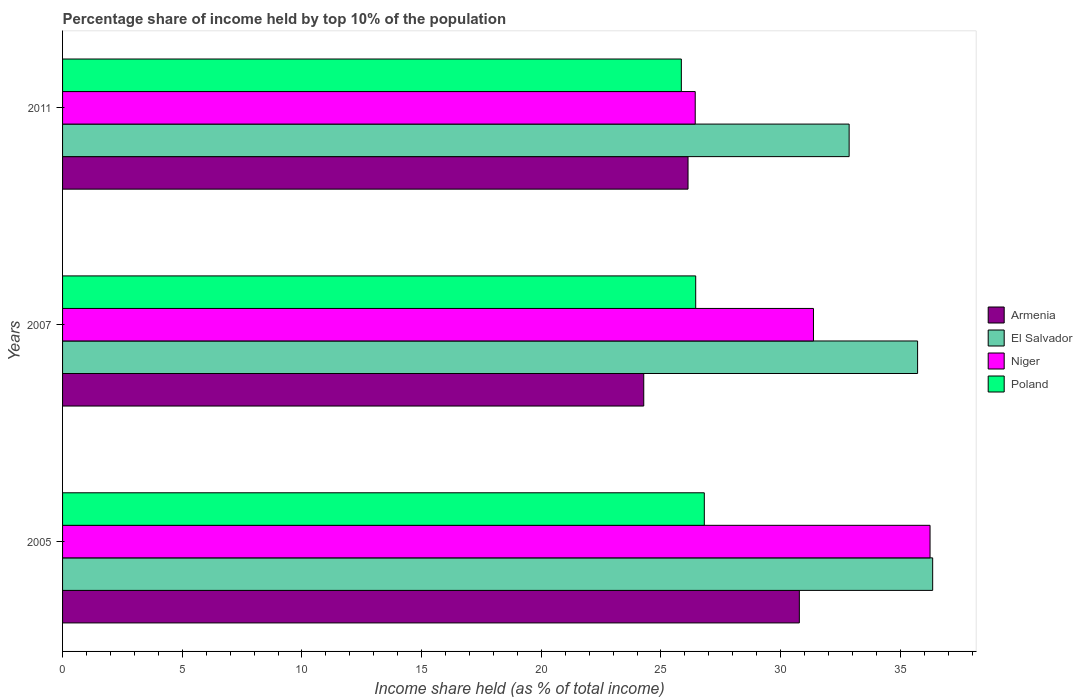How many different coloured bars are there?
Your answer should be very brief. 4. How many groups of bars are there?
Offer a terse response. 3. Are the number of bars per tick equal to the number of legend labels?
Make the answer very short. Yes. What is the percentage share of income held by top 10% of the population in El Salvador in 2011?
Provide a succinct answer. 32.86. Across all years, what is the maximum percentage share of income held by top 10% of the population in Poland?
Your answer should be compact. 26.81. Across all years, what is the minimum percentage share of income held by top 10% of the population in El Salvador?
Keep it short and to the point. 32.86. What is the total percentage share of income held by top 10% of the population in El Salvador in the graph?
Give a very brief answer. 104.93. What is the difference between the percentage share of income held by top 10% of the population in Niger in 2005 and that in 2011?
Offer a very short reply. 9.81. What is the difference between the percentage share of income held by top 10% of the population in Poland in 2011 and the percentage share of income held by top 10% of the population in Niger in 2007?
Keep it short and to the point. -5.52. What is the average percentage share of income held by top 10% of the population in Niger per year?
Ensure brevity in your answer.  31.35. In the year 2005, what is the difference between the percentage share of income held by top 10% of the population in El Salvador and percentage share of income held by top 10% of the population in Poland?
Give a very brief answer. 9.54. What is the ratio of the percentage share of income held by top 10% of the population in El Salvador in 2007 to that in 2011?
Make the answer very short. 1.09. What is the difference between the highest and the second highest percentage share of income held by top 10% of the population in El Salvador?
Your answer should be very brief. 0.63. What is the difference between the highest and the lowest percentage share of income held by top 10% of the population in El Salvador?
Make the answer very short. 3.49. Is it the case that in every year, the sum of the percentage share of income held by top 10% of the population in El Salvador and percentage share of income held by top 10% of the population in Armenia is greater than the sum of percentage share of income held by top 10% of the population in Poland and percentage share of income held by top 10% of the population in Niger?
Keep it short and to the point. Yes. What does the 2nd bar from the top in 2007 represents?
Give a very brief answer. Niger. What does the 1st bar from the bottom in 2005 represents?
Ensure brevity in your answer.  Armenia. Is it the case that in every year, the sum of the percentage share of income held by top 10% of the population in Armenia and percentage share of income held by top 10% of the population in Poland is greater than the percentage share of income held by top 10% of the population in El Salvador?
Your response must be concise. Yes. What is the difference between two consecutive major ticks on the X-axis?
Give a very brief answer. 5. Are the values on the major ticks of X-axis written in scientific E-notation?
Your response must be concise. No. Does the graph contain grids?
Your response must be concise. No. Where does the legend appear in the graph?
Keep it short and to the point. Center right. How many legend labels are there?
Keep it short and to the point. 4. What is the title of the graph?
Your response must be concise. Percentage share of income held by top 10% of the population. What is the label or title of the X-axis?
Keep it short and to the point. Income share held (as % of total income). What is the label or title of the Y-axis?
Provide a short and direct response. Years. What is the Income share held (as % of total income) of Armenia in 2005?
Your answer should be compact. 30.78. What is the Income share held (as % of total income) in El Salvador in 2005?
Provide a short and direct response. 36.35. What is the Income share held (as % of total income) in Niger in 2005?
Offer a terse response. 36.24. What is the Income share held (as % of total income) of Poland in 2005?
Keep it short and to the point. 26.81. What is the Income share held (as % of total income) in Armenia in 2007?
Ensure brevity in your answer.  24.28. What is the Income share held (as % of total income) of El Salvador in 2007?
Keep it short and to the point. 35.72. What is the Income share held (as % of total income) of Niger in 2007?
Offer a terse response. 31.37. What is the Income share held (as % of total income) of Poland in 2007?
Provide a succinct answer. 26.45. What is the Income share held (as % of total income) in Armenia in 2011?
Make the answer very short. 26.13. What is the Income share held (as % of total income) of El Salvador in 2011?
Offer a very short reply. 32.86. What is the Income share held (as % of total income) in Niger in 2011?
Ensure brevity in your answer.  26.43. What is the Income share held (as % of total income) in Poland in 2011?
Your answer should be very brief. 25.85. Across all years, what is the maximum Income share held (as % of total income) of Armenia?
Provide a short and direct response. 30.78. Across all years, what is the maximum Income share held (as % of total income) in El Salvador?
Your response must be concise. 36.35. Across all years, what is the maximum Income share held (as % of total income) of Niger?
Offer a very short reply. 36.24. Across all years, what is the maximum Income share held (as % of total income) of Poland?
Provide a short and direct response. 26.81. Across all years, what is the minimum Income share held (as % of total income) in Armenia?
Ensure brevity in your answer.  24.28. Across all years, what is the minimum Income share held (as % of total income) of El Salvador?
Your answer should be compact. 32.86. Across all years, what is the minimum Income share held (as % of total income) in Niger?
Make the answer very short. 26.43. Across all years, what is the minimum Income share held (as % of total income) of Poland?
Your response must be concise. 25.85. What is the total Income share held (as % of total income) of Armenia in the graph?
Give a very brief answer. 81.19. What is the total Income share held (as % of total income) in El Salvador in the graph?
Your response must be concise. 104.93. What is the total Income share held (as % of total income) of Niger in the graph?
Your answer should be compact. 94.04. What is the total Income share held (as % of total income) in Poland in the graph?
Your answer should be very brief. 79.11. What is the difference between the Income share held (as % of total income) of Armenia in 2005 and that in 2007?
Offer a very short reply. 6.5. What is the difference between the Income share held (as % of total income) in El Salvador in 2005 and that in 2007?
Ensure brevity in your answer.  0.63. What is the difference between the Income share held (as % of total income) of Niger in 2005 and that in 2007?
Your response must be concise. 4.87. What is the difference between the Income share held (as % of total income) of Poland in 2005 and that in 2007?
Offer a terse response. 0.36. What is the difference between the Income share held (as % of total income) in Armenia in 2005 and that in 2011?
Provide a short and direct response. 4.65. What is the difference between the Income share held (as % of total income) of El Salvador in 2005 and that in 2011?
Keep it short and to the point. 3.49. What is the difference between the Income share held (as % of total income) of Niger in 2005 and that in 2011?
Your response must be concise. 9.81. What is the difference between the Income share held (as % of total income) of Armenia in 2007 and that in 2011?
Offer a terse response. -1.85. What is the difference between the Income share held (as % of total income) of El Salvador in 2007 and that in 2011?
Give a very brief answer. 2.86. What is the difference between the Income share held (as % of total income) of Niger in 2007 and that in 2011?
Your answer should be compact. 4.94. What is the difference between the Income share held (as % of total income) in Poland in 2007 and that in 2011?
Make the answer very short. 0.6. What is the difference between the Income share held (as % of total income) in Armenia in 2005 and the Income share held (as % of total income) in El Salvador in 2007?
Offer a very short reply. -4.94. What is the difference between the Income share held (as % of total income) of Armenia in 2005 and the Income share held (as % of total income) of Niger in 2007?
Give a very brief answer. -0.59. What is the difference between the Income share held (as % of total income) in Armenia in 2005 and the Income share held (as % of total income) in Poland in 2007?
Your answer should be very brief. 4.33. What is the difference between the Income share held (as % of total income) of El Salvador in 2005 and the Income share held (as % of total income) of Niger in 2007?
Your answer should be very brief. 4.98. What is the difference between the Income share held (as % of total income) of El Salvador in 2005 and the Income share held (as % of total income) of Poland in 2007?
Keep it short and to the point. 9.9. What is the difference between the Income share held (as % of total income) in Niger in 2005 and the Income share held (as % of total income) in Poland in 2007?
Ensure brevity in your answer.  9.79. What is the difference between the Income share held (as % of total income) of Armenia in 2005 and the Income share held (as % of total income) of El Salvador in 2011?
Offer a very short reply. -2.08. What is the difference between the Income share held (as % of total income) in Armenia in 2005 and the Income share held (as % of total income) in Niger in 2011?
Offer a very short reply. 4.35. What is the difference between the Income share held (as % of total income) in Armenia in 2005 and the Income share held (as % of total income) in Poland in 2011?
Offer a terse response. 4.93. What is the difference between the Income share held (as % of total income) of El Salvador in 2005 and the Income share held (as % of total income) of Niger in 2011?
Make the answer very short. 9.92. What is the difference between the Income share held (as % of total income) in El Salvador in 2005 and the Income share held (as % of total income) in Poland in 2011?
Ensure brevity in your answer.  10.5. What is the difference between the Income share held (as % of total income) of Niger in 2005 and the Income share held (as % of total income) of Poland in 2011?
Make the answer very short. 10.39. What is the difference between the Income share held (as % of total income) in Armenia in 2007 and the Income share held (as % of total income) in El Salvador in 2011?
Make the answer very short. -8.58. What is the difference between the Income share held (as % of total income) in Armenia in 2007 and the Income share held (as % of total income) in Niger in 2011?
Keep it short and to the point. -2.15. What is the difference between the Income share held (as % of total income) in Armenia in 2007 and the Income share held (as % of total income) in Poland in 2011?
Offer a very short reply. -1.57. What is the difference between the Income share held (as % of total income) of El Salvador in 2007 and the Income share held (as % of total income) of Niger in 2011?
Your response must be concise. 9.29. What is the difference between the Income share held (as % of total income) in El Salvador in 2007 and the Income share held (as % of total income) in Poland in 2011?
Your answer should be very brief. 9.87. What is the difference between the Income share held (as % of total income) in Niger in 2007 and the Income share held (as % of total income) in Poland in 2011?
Your answer should be very brief. 5.52. What is the average Income share held (as % of total income) of Armenia per year?
Offer a terse response. 27.06. What is the average Income share held (as % of total income) of El Salvador per year?
Offer a very short reply. 34.98. What is the average Income share held (as % of total income) in Niger per year?
Your answer should be compact. 31.35. What is the average Income share held (as % of total income) in Poland per year?
Provide a succinct answer. 26.37. In the year 2005, what is the difference between the Income share held (as % of total income) of Armenia and Income share held (as % of total income) of El Salvador?
Give a very brief answer. -5.57. In the year 2005, what is the difference between the Income share held (as % of total income) in Armenia and Income share held (as % of total income) in Niger?
Your answer should be very brief. -5.46. In the year 2005, what is the difference between the Income share held (as % of total income) in Armenia and Income share held (as % of total income) in Poland?
Ensure brevity in your answer.  3.97. In the year 2005, what is the difference between the Income share held (as % of total income) of El Salvador and Income share held (as % of total income) of Niger?
Make the answer very short. 0.11. In the year 2005, what is the difference between the Income share held (as % of total income) in El Salvador and Income share held (as % of total income) in Poland?
Your answer should be very brief. 9.54. In the year 2005, what is the difference between the Income share held (as % of total income) of Niger and Income share held (as % of total income) of Poland?
Your answer should be very brief. 9.43. In the year 2007, what is the difference between the Income share held (as % of total income) in Armenia and Income share held (as % of total income) in El Salvador?
Offer a terse response. -11.44. In the year 2007, what is the difference between the Income share held (as % of total income) in Armenia and Income share held (as % of total income) in Niger?
Your response must be concise. -7.09. In the year 2007, what is the difference between the Income share held (as % of total income) in Armenia and Income share held (as % of total income) in Poland?
Ensure brevity in your answer.  -2.17. In the year 2007, what is the difference between the Income share held (as % of total income) in El Salvador and Income share held (as % of total income) in Niger?
Ensure brevity in your answer.  4.35. In the year 2007, what is the difference between the Income share held (as % of total income) in El Salvador and Income share held (as % of total income) in Poland?
Give a very brief answer. 9.27. In the year 2007, what is the difference between the Income share held (as % of total income) in Niger and Income share held (as % of total income) in Poland?
Provide a succinct answer. 4.92. In the year 2011, what is the difference between the Income share held (as % of total income) in Armenia and Income share held (as % of total income) in El Salvador?
Offer a very short reply. -6.73. In the year 2011, what is the difference between the Income share held (as % of total income) of Armenia and Income share held (as % of total income) of Poland?
Offer a terse response. 0.28. In the year 2011, what is the difference between the Income share held (as % of total income) of El Salvador and Income share held (as % of total income) of Niger?
Your answer should be very brief. 6.43. In the year 2011, what is the difference between the Income share held (as % of total income) in El Salvador and Income share held (as % of total income) in Poland?
Your response must be concise. 7.01. In the year 2011, what is the difference between the Income share held (as % of total income) in Niger and Income share held (as % of total income) in Poland?
Your answer should be compact. 0.58. What is the ratio of the Income share held (as % of total income) in Armenia in 2005 to that in 2007?
Ensure brevity in your answer.  1.27. What is the ratio of the Income share held (as % of total income) in El Salvador in 2005 to that in 2007?
Your answer should be compact. 1.02. What is the ratio of the Income share held (as % of total income) of Niger in 2005 to that in 2007?
Your answer should be very brief. 1.16. What is the ratio of the Income share held (as % of total income) in Poland in 2005 to that in 2007?
Keep it short and to the point. 1.01. What is the ratio of the Income share held (as % of total income) of Armenia in 2005 to that in 2011?
Ensure brevity in your answer.  1.18. What is the ratio of the Income share held (as % of total income) of El Salvador in 2005 to that in 2011?
Your answer should be compact. 1.11. What is the ratio of the Income share held (as % of total income) of Niger in 2005 to that in 2011?
Make the answer very short. 1.37. What is the ratio of the Income share held (as % of total income) in Poland in 2005 to that in 2011?
Your answer should be very brief. 1.04. What is the ratio of the Income share held (as % of total income) of Armenia in 2007 to that in 2011?
Offer a terse response. 0.93. What is the ratio of the Income share held (as % of total income) of El Salvador in 2007 to that in 2011?
Give a very brief answer. 1.09. What is the ratio of the Income share held (as % of total income) of Niger in 2007 to that in 2011?
Offer a terse response. 1.19. What is the ratio of the Income share held (as % of total income) of Poland in 2007 to that in 2011?
Your answer should be compact. 1.02. What is the difference between the highest and the second highest Income share held (as % of total income) of Armenia?
Offer a very short reply. 4.65. What is the difference between the highest and the second highest Income share held (as % of total income) in El Salvador?
Ensure brevity in your answer.  0.63. What is the difference between the highest and the second highest Income share held (as % of total income) in Niger?
Keep it short and to the point. 4.87. What is the difference between the highest and the second highest Income share held (as % of total income) in Poland?
Ensure brevity in your answer.  0.36. What is the difference between the highest and the lowest Income share held (as % of total income) of El Salvador?
Offer a very short reply. 3.49. What is the difference between the highest and the lowest Income share held (as % of total income) in Niger?
Provide a short and direct response. 9.81. 